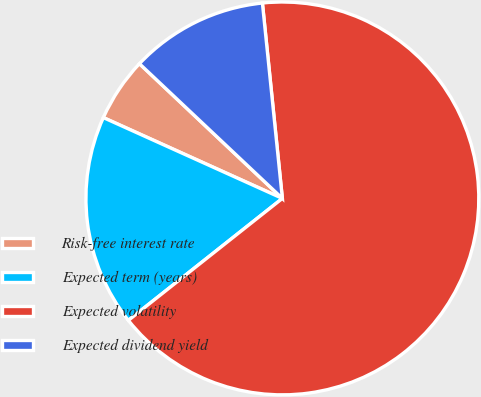<chart> <loc_0><loc_0><loc_500><loc_500><pie_chart><fcel>Risk-free interest rate<fcel>Expected term (years)<fcel>Expected volatility<fcel>Expected dividend yield<nl><fcel>5.28%<fcel>17.41%<fcel>65.96%<fcel>11.35%<nl></chart> 